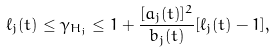<formula> <loc_0><loc_0><loc_500><loc_500>\ell _ { j } ( t ) \leq \gamma _ { H _ { j } } \leq 1 + \frac { [ a _ { j } ( t ) ] ^ { 2 } } { b _ { j } ( t ) } [ \ell _ { j } ( t ) - 1 ] ,</formula> 